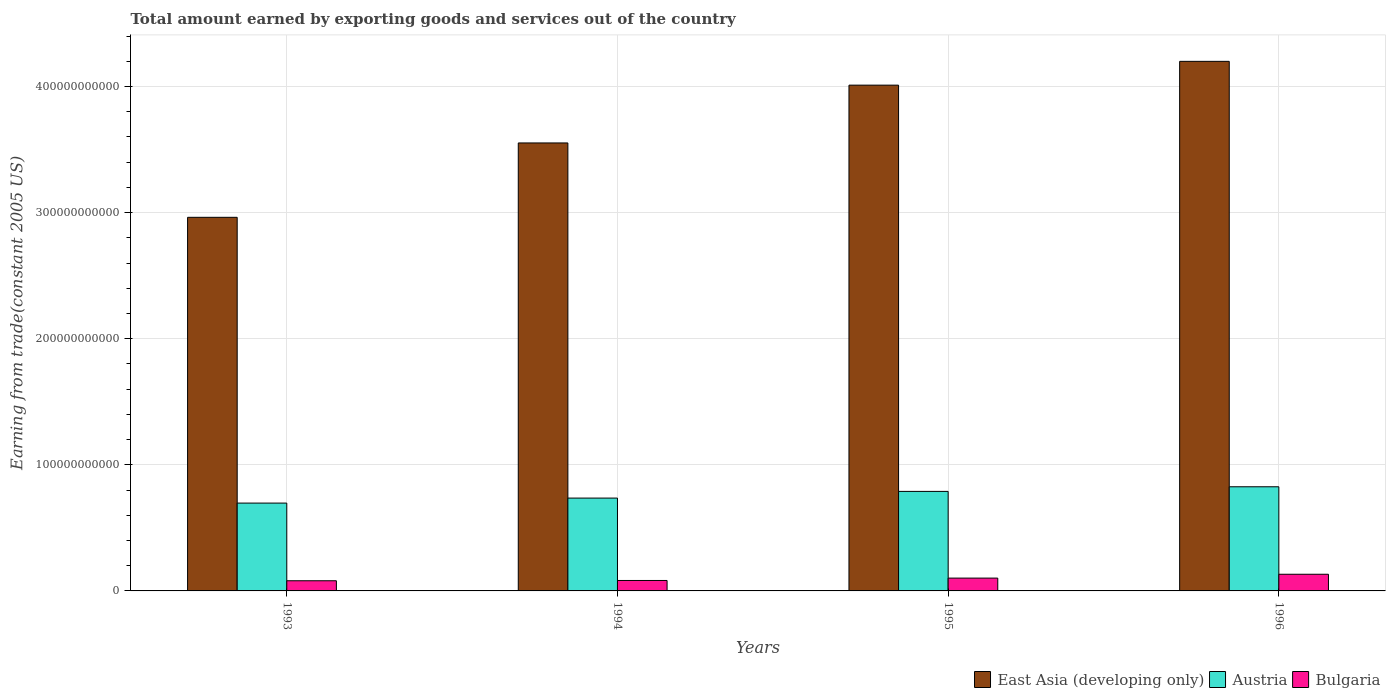How many different coloured bars are there?
Your answer should be compact. 3. How many groups of bars are there?
Your answer should be very brief. 4. Are the number of bars on each tick of the X-axis equal?
Give a very brief answer. Yes. How many bars are there on the 1st tick from the right?
Offer a terse response. 3. What is the label of the 4th group of bars from the left?
Keep it short and to the point. 1996. In how many cases, is the number of bars for a given year not equal to the number of legend labels?
Your response must be concise. 0. What is the total amount earned by exporting goods and services in Bulgaria in 1995?
Offer a terse response. 1.02e+1. Across all years, what is the maximum total amount earned by exporting goods and services in East Asia (developing only)?
Offer a terse response. 4.20e+11. Across all years, what is the minimum total amount earned by exporting goods and services in Austria?
Your answer should be compact. 6.97e+1. In which year was the total amount earned by exporting goods and services in Bulgaria maximum?
Give a very brief answer. 1996. In which year was the total amount earned by exporting goods and services in Austria minimum?
Offer a terse response. 1993. What is the total total amount earned by exporting goods and services in East Asia (developing only) in the graph?
Offer a terse response. 1.47e+12. What is the difference between the total amount earned by exporting goods and services in Bulgaria in 1995 and that in 1996?
Give a very brief answer. -3.05e+09. What is the difference between the total amount earned by exporting goods and services in Austria in 1994 and the total amount earned by exporting goods and services in Bulgaria in 1995?
Make the answer very short. 6.35e+1. What is the average total amount earned by exporting goods and services in Austria per year?
Offer a terse response. 7.62e+1. In the year 1995, what is the difference between the total amount earned by exporting goods and services in Bulgaria and total amount earned by exporting goods and services in Austria?
Offer a very short reply. -6.88e+1. In how many years, is the total amount earned by exporting goods and services in East Asia (developing only) greater than 220000000000 US$?
Provide a succinct answer. 4. What is the ratio of the total amount earned by exporting goods and services in East Asia (developing only) in 1993 to that in 1995?
Make the answer very short. 0.74. Is the total amount earned by exporting goods and services in Austria in 1994 less than that in 1996?
Your answer should be compact. Yes. Is the difference between the total amount earned by exporting goods and services in Bulgaria in 1994 and 1995 greater than the difference between the total amount earned by exporting goods and services in Austria in 1994 and 1995?
Provide a short and direct response. Yes. What is the difference between the highest and the second highest total amount earned by exporting goods and services in East Asia (developing only)?
Your answer should be compact. 1.89e+1. What is the difference between the highest and the lowest total amount earned by exporting goods and services in Austria?
Provide a succinct answer. 1.29e+1. Is the sum of the total amount earned by exporting goods and services in Bulgaria in 1993 and 1994 greater than the maximum total amount earned by exporting goods and services in Austria across all years?
Make the answer very short. No. What does the 3rd bar from the left in 1993 represents?
Your answer should be very brief. Bulgaria. What does the 1st bar from the right in 1993 represents?
Give a very brief answer. Bulgaria. Is it the case that in every year, the sum of the total amount earned by exporting goods and services in Austria and total amount earned by exporting goods and services in Bulgaria is greater than the total amount earned by exporting goods and services in East Asia (developing only)?
Ensure brevity in your answer.  No. How many bars are there?
Your answer should be very brief. 12. Are all the bars in the graph horizontal?
Provide a short and direct response. No. How many years are there in the graph?
Your response must be concise. 4. What is the difference between two consecutive major ticks on the Y-axis?
Your answer should be compact. 1.00e+11. Are the values on the major ticks of Y-axis written in scientific E-notation?
Offer a very short reply. No. Does the graph contain any zero values?
Your answer should be compact. No. Does the graph contain grids?
Your response must be concise. Yes. Where does the legend appear in the graph?
Provide a short and direct response. Bottom right. How many legend labels are there?
Your response must be concise. 3. How are the legend labels stacked?
Ensure brevity in your answer.  Horizontal. What is the title of the graph?
Give a very brief answer. Total amount earned by exporting goods and services out of the country. What is the label or title of the X-axis?
Provide a succinct answer. Years. What is the label or title of the Y-axis?
Your answer should be compact. Earning from trade(constant 2005 US). What is the Earning from trade(constant 2005 US) in East Asia (developing only) in 1993?
Give a very brief answer. 2.96e+11. What is the Earning from trade(constant 2005 US) of Austria in 1993?
Give a very brief answer. 6.97e+1. What is the Earning from trade(constant 2005 US) in Bulgaria in 1993?
Give a very brief answer. 8.06e+09. What is the Earning from trade(constant 2005 US) in East Asia (developing only) in 1994?
Ensure brevity in your answer.  3.55e+11. What is the Earning from trade(constant 2005 US) in Austria in 1994?
Your answer should be very brief. 7.36e+1. What is the Earning from trade(constant 2005 US) in Bulgaria in 1994?
Offer a very short reply. 8.28e+09. What is the Earning from trade(constant 2005 US) in East Asia (developing only) in 1995?
Provide a succinct answer. 4.01e+11. What is the Earning from trade(constant 2005 US) in Austria in 1995?
Make the answer very short. 7.89e+1. What is the Earning from trade(constant 2005 US) of Bulgaria in 1995?
Make the answer very short. 1.02e+1. What is the Earning from trade(constant 2005 US) of East Asia (developing only) in 1996?
Your response must be concise. 4.20e+11. What is the Earning from trade(constant 2005 US) in Austria in 1996?
Ensure brevity in your answer.  8.26e+1. What is the Earning from trade(constant 2005 US) in Bulgaria in 1996?
Keep it short and to the point. 1.32e+1. Across all years, what is the maximum Earning from trade(constant 2005 US) of East Asia (developing only)?
Your response must be concise. 4.20e+11. Across all years, what is the maximum Earning from trade(constant 2005 US) in Austria?
Your answer should be very brief. 8.26e+1. Across all years, what is the maximum Earning from trade(constant 2005 US) of Bulgaria?
Provide a succinct answer. 1.32e+1. Across all years, what is the minimum Earning from trade(constant 2005 US) in East Asia (developing only)?
Offer a terse response. 2.96e+11. Across all years, what is the minimum Earning from trade(constant 2005 US) in Austria?
Offer a terse response. 6.97e+1. Across all years, what is the minimum Earning from trade(constant 2005 US) of Bulgaria?
Offer a terse response. 8.06e+09. What is the total Earning from trade(constant 2005 US) of East Asia (developing only) in the graph?
Your answer should be compact. 1.47e+12. What is the total Earning from trade(constant 2005 US) of Austria in the graph?
Provide a short and direct response. 3.05e+11. What is the total Earning from trade(constant 2005 US) in Bulgaria in the graph?
Offer a very short reply. 3.97e+1. What is the difference between the Earning from trade(constant 2005 US) in East Asia (developing only) in 1993 and that in 1994?
Provide a succinct answer. -5.90e+1. What is the difference between the Earning from trade(constant 2005 US) in Austria in 1993 and that in 1994?
Keep it short and to the point. -3.96e+09. What is the difference between the Earning from trade(constant 2005 US) of Bulgaria in 1993 and that in 1994?
Your response must be concise. -2.23e+08. What is the difference between the Earning from trade(constant 2005 US) in East Asia (developing only) in 1993 and that in 1995?
Ensure brevity in your answer.  -1.05e+11. What is the difference between the Earning from trade(constant 2005 US) of Austria in 1993 and that in 1995?
Keep it short and to the point. -9.27e+09. What is the difference between the Earning from trade(constant 2005 US) of Bulgaria in 1993 and that in 1995?
Your answer should be compact. -2.11e+09. What is the difference between the Earning from trade(constant 2005 US) of East Asia (developing only) in 1993 and that in 1996?
Your response must be concise. -1.24e+11. What is the difference between the Earning from trade(constant 2005 US) in Austria in 1993 and that in 1996?
Ensure brevity in your answer.  -1.29e+1. What is the difference between the Earning from trade(constant 2005 US) in Bulgaria in 1993 and that in 1996?
Ensure brevity in your answer.  -5.16e+09. What is the difference between the Earning from trade(constant 2005 US) in East Asia (developing only) in 1994 and that in 1995?
Your answer should be very brief. -4.58e+1. What is the difference between the Earning from trade(constant 2005 US) of Austria in 1994 and that in 1995?
Offer a terse response. -5.30e+09. What is the difference between the Earning from trade(constant 2005 US) of Bulgaria in 1994 and that in 1995?
Your answer should be very brief. -1.89e+09. What is the difference between the Earning from trade(constant 2005 US) in East Asia (developing only) in 1994 and that in 1996?
Ensure brevity in your answer.  -6.47e+1. What is the difference between the Earning from trade(constant 2005 US) in Austria in 1994 and that in 1996?
Offer a terse response. -8.97e+09. What is the difference between the Earning from trade(constant 2005 US) in Bulgaria in 1994 and that in 1996?
Provide a succinct answer. -4.94e+09. What is the difference between the Earning from trade(constant 2005 US) in East Asia (developing only) in 1995 and that in 1996?
Your answer should be very brief. -1.89e+1. What is the difference between the Earning from trade(constant 2005 US) of Austria in 1995 and that in 1996?
Keep it short and to the point. -3.66e+09. What is the difference between the Earning from trade(constant 2005 US) in Bulgaria in 1995 and that in 1996?
Your response must be concise. -3.05e+09. What is the difference between the Earning from trade(constant 2005 US) in East Asia (developing only) in 1993 and the Earning from trade(constant 2005 US) in Austria in 1994?
Your answer should be compact. 2.23e+11. What is the difference between the Earning from trade(constant 2005 US) in East Asia (developing only) in 1993 and the Earning from trade(constant 2005 US) in Bulgaria in 1994?
Provide a succinct answer. 2.88e+11. What is the difference between the Earning from trade(constant 2005 US) of Austria in 1993 and the Earning from trade(constant 2005 US) of Bulgaria in 1994?
Provide a short and direct response. 6.14e+1. What is the difference between the Earning from trade(constant 2005 US) of East Asia (developing only) in 1993 and the Earning from trade(constant 2005 US) of Austria in 1995?
Keep it short and to the point. 2.17e+11. What is the difference between the Earning from trade(constant 2005 US) in East Asia (developing only) in 1993 and the Earning from trade(constant 2005 US) in Bulgaria in 1995?
Offer a very short reply. 2.86e+11. What is the difference between the Earning from trade(constant 2005 US) in Austria in 1993 and the Earning from trade(constant 2005 US) in Bulgaria in 1995?
Make the answer very short. 5.95e+1. What is the difference between the Earning from trade(constant 2005 US) in East Asia (developing only) in 1993 and the Earning from trade(constant 2005 US) in Austria in 1996?
Provide a succinct answer. 2.14e+11. What is the difference between the Earning from trade(constant 2005 US) in East Asia (developing only) in 1993 and the Earning from trade(constant 2005 US) in Bulgaria in 1996?
Give a very brief answer. 2.83e+11. What is the difference between the Earning from trade(constant 2005 US) in Austria in 1993 and the Earning from trade(constant 2005 US) in Bulgaria in 1996?
Your answer should be compact. 5.64e+1. What is the difference between the Earning from trade(constant 2005 US) of East Asia (developing only) in 1994 and the Earning from trade(constant 2005 US) of Austria in 1995?
Provide a short and direct response. 2.76e+11. What is the difference between the Earning from trade(constant 2005 US) of East Asia (developing only) in 1994 and the Earning from trade(constant 2005 US) of Bulgaria in 1995?
Offer a terse response. 3.45e+11. What is the difference between the Earning from trade(constant 2005 US) in Austria in 1994 and the Earning from trade(constant 2005 US) in Bulgaria in 1995?
Provide a succinct answer. 6.35e+1. What is the difference between the Earning from trade(constant 2005 US) of East Asia (developing only) in 1994 and the Earning from trade(constant 2005 US) of Austria in 1996?
Ensure brevity in your answer.  2.73e+11. What is the difference between the Earning from trade(constant 2005 US) of East Asia (developing only) in 1994 and the Earning from trade(constant 2005 US) of Bulgaria in 1996?
Your answer should be compact. 3.42e+11. What is the difference between the Earning from trade(constant 2005 US) in Austria in 1994 and the Earning from trade(constant 2005 US) in Bulgaria in 1996?
Offer a very short reply. 6.04e+1. What is the difference between the Earning from trade(constant 2005 US) of East Asia (developing only) in 1995 and the Earning from trade(constant 2005 US) of Austria in 1996?
Make the answer very short. 3.19e+11. What is the difference between the Earning from trade(constant 2005 US) in East Asia (developing only) in 1995 and the Earning from trade(constant 2005 US) in Bulgaria in 1996?
Your answer should be very brief. 3.88e+11. What is the difference between the Earning from trade(constant 2005 US) in Austria in 1995 and the Earning from trade(constant 2005 US) in Bulgaria in 1996?
Make the answer very short. 6.57e+1. What is the average Earning from trade(constant 2005 US) of East Asia (developing only) per year?
Your answer should be very brief. 3.68e+11. What is the average Earning from trade(constant 2005 US) of Austria per year?
Provide a short and direct response. 7.62e+1. What is the average Earning from trade(constant 2005 US) of Bulgaria per year?
Make the answer very short. 9.93e+09. In the year 1993, what is the difference between the Earning from trade(constant 2005 US) of East Asia (developing only) and Earning from trade(constant 2005 US) of Austria?
Your answer should be very brief. 2.27e+11. In the year 1993, what is the difference between the Earning from trade(constant 2005 US) in East Asia (developing only) and Earning from trade(constant 2005 US) in Bulgaria?
Provide a succinct answer. 2.88e+11. In the year 1993, what is the difference between the Earning from trade(constant 2005 US) in Austria and Earning from trade(constant 2005 US) in Bulgaria?
Offer a very short reply. 6.16e+1. In the year 1994, what is the difference between the Earning from trade(constant 2005 US) in East Asia (developing only) and Earning from trade(constant 2005 US) in Austria?
Give a very brief answer. 2.82e+11. In the year 1994, what is the difference between the Earning from trade(constant 2005 US) of East Asia (developing only) and Earning from trade(constant 2005 US) of Bulgaria?
Keep it short and to the point. 3.47e+11. In the year 1994, what is the difference between the Earning from trade(constant 2005 US) of Austria and Earning from trade(constant 2005 US) of Bulgaria?
Offer a terse response. 6.53e+1. In the year 1995, what is the difference between the Earning from trade(constant 2005 US) in East Asia (developing only) and Earning from trade(constant 2005 US) in Austria?
Provide a succinct answer. 3.22e+11. In the year 1995, what is the difference between the Earning from trade(constant 2005 US) of East Asia (developing only) and Earning from trade(constant 2005 US) of Bulgaria?
Offer a very short reply. 3.91e+11. In the year 1995, what is the difference between the Earning from trade(constant 2005 US) in Austria and Earning from trade(constant 2005 US) in Bulgaria?
Your answer should be very brief. 6.88e+1. In the year 1996, what is the difference between the Earning from trade(constant 2005 US) in East Asia (developing only) and Earning from trade(constant 2005 US) in Austria?
Provide a succinct answer. 3.37e+11. In the year 1996, what is the difference between the Earning from trade(constant 2005 US) of East Asia (developing only) and Earning from trade(constant 2005 US) of Bulgaria?
Your answer should be compact. 4.07e+11. In the year 1996, what is the difference between the Earning from trade(constant 2005 US) of Austria and Earning from trade(constant 2005 US) of Bulgaria?
Provide a short and direct response. 6.94e+1. What is the ratio of the Earning from trade(constant 2005 US) of East Asia (developing only) in 1993 to that in 1994?
Provide a succinct answer. 0.83. What is the ratio of the Earning from trade(constant 2005 US) in Austria in 1993 to that in 1994?
Offer a very short reply. 0.95. What is the ratio of the Earning from trade(constant 2005 US) in Bulgaria in 1993 to that in 1994?
Provide a short and direct response. 0.97. What is the ratio of the Earning from trade(constant 2005 US) in East Asia (developing only) in 1993 to that in 1995?
Offer a terse response. 0.74. What is the ratio of the Earning from trade(constant 2005 US) of Austria in 1993 to that in 1995?
Provide a succinct answer. 0.88. What is the ratio of the Earning from trade(constant 2005 US) of Bulgaria in 1993 to that in 1995?
Provide a succinct answer. 0.79. What is the ratio of the Earning from trade(constant 2005 US) in East Asia (developing only) in 1993 to that in 1996?
Provide a short and direct response. 0.71. What is the ratio of the Earning from trade(constant 2005 US) of Austria in 1993 to that in 1996?
Your answer should be very brief. 0.84. What is the ratio of the Earning from trade(constant 2005 US) of Bulgaria in 1993 to that in 1996?
Make the answer very short. 0.61. What is the ratio of the Earning from trade(constant 2005 US) in East Asia (developing only) in 1994 to that in 1995?
Provide a succinct answer. 0.89. What is the ratio of the Earning from trade(constant 2005 US) of Austria in 1994 to that in 1995?
Your response must be concise. 0.93. What is the ratio of the Earning from trade(constant 2005 US) of Bulgaria in 1994 to that in 1995?
Your answer should be very brief. 0.81. What is the ratio of the Earning from trade(constant 2005 US) of East Asia (developing only) in 1994 to that in 1996?
Provide a short and direct response. 0.85. What is the ratio of the Earning from trade(constant 2005 US) of Austria in 1994 to that in 1996?
Give a very brief answer. 0.89. What is the ratio of the Earning from trade(constant 2005 US) in Bulgaria in 1994 to that in 1996?
Give a very brief answer. 0.63. What is the ratio of the Earning from trade(constant 2005 US) in East Asia (developing only) in 1995 to that in 1996?
Your answer should be compact. 0.96. What is the ratio of the Earning from trade(constant 2005 US) in Austria in 1995 to that in 1996?
Offer a very short reply. 0.96. What is the ratio of the Earning from trade(constant 2005 US) of Bulgaria in 1995 to that in 1996?
Make the answer very short. 0.77. What is the difference between the highest and the second highest Earning from trade(constant 2005 US) of East Asia (developing only)?
Make the answer very short. 1.89e+1. What is the difference between the highest and the second highest Earning from trade(constant 2005 US) of Austria?
Provide a short and direct response. 3.66e+09. What is the difference between the highest and the second highest Earning from trade(constant 2005 US) of Bulgaria?
Ensure brevity in your answer.  3.05e+09. What is the difference between the highest and the lowest Earning from trade(constant 2005 US) in East Asia (developing only)?
Your answer should be very brief. 1.24e+11. What is the difference between the highest and the lowest Earning from trade(constant 2005 US) in Austria?
Offer a terse response. 1.29e+1. What is the difference between the highest and the lowest Earning from trade(constant 2005 US) in Bulgaria?
Your answer should be very brief. 5.16e+09. 